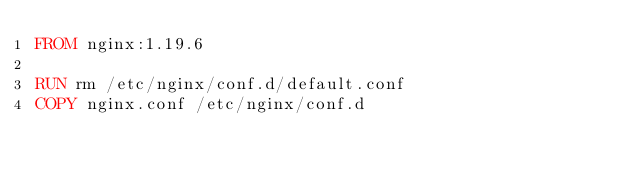<code> <loc_0><loc_0><loc_500><loc_500><_Dockerfile_>FROM nginx:1.19.6

RUN rm /etc/nginx/conf.d/default.conf
COPY nginx.conf /etc/nginx/conf.d</code> 